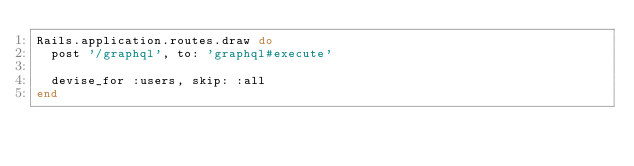<code> <loc_0><loc_0><loc_500><loc_500><_Ruby_>Rails.application.routes.draw do
  post '/graphql', to: 'graphql#execute'

  devise_for :users, skip: :all
end</code> 